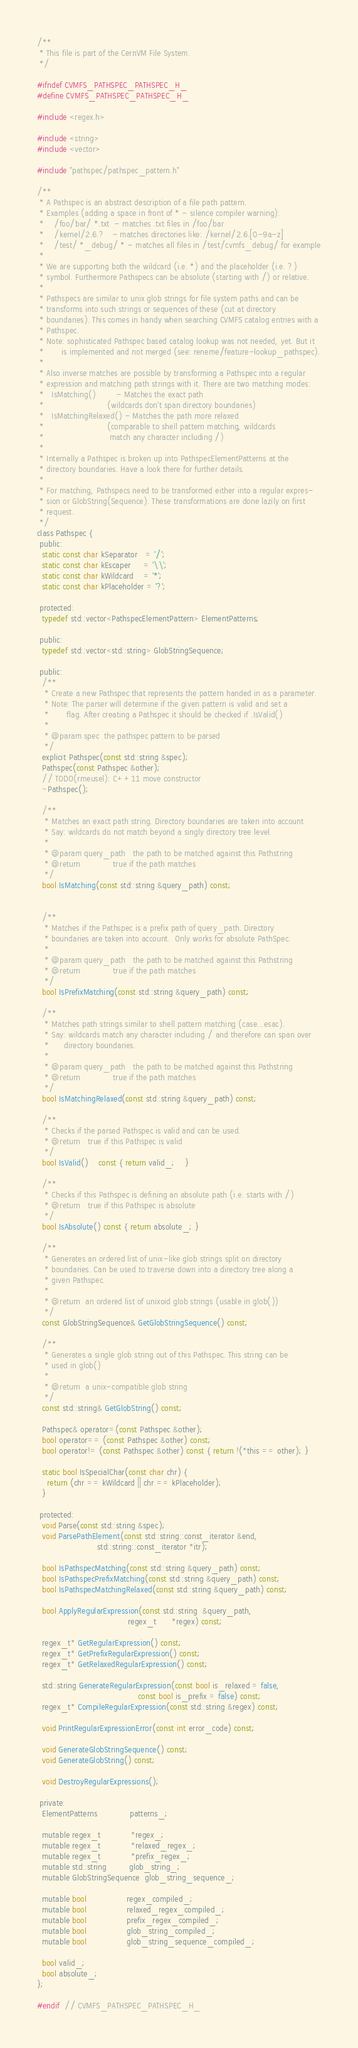Convert code to text. <code><loc_0><loc_0><loc_500><loc_500><_C_>/**
 * This file is part of the CernVM File System.
 */

#ifndef CVMFS_PATHSPEC_PATHSPEC_H_
#define CVMFS_PATHSPEC_PATHSPEC_H_

#include <regex.h>

#include <string>
#include <vector>

#include "pathspec/pathspec_pattern.h"

/**
 * A Pathspec is an abstract description of a file path pattern.
 * Examples (adding a space in front of * - silence compiler warning):
 *    /foo/bar/ *.txt  - matches .txt files in /foo/bar
 *    /kernel/2.6.?   - matches directories like: /kernel/2.6.[0-9a-z]
 *    /test/ *_debug/ * - matches all files in /test/cvmfs_debug/ for example
 *
 * We are supporting both the wildcard (i.e. *) and the placeholder (i.e. ?)
 * symbol. Furthermore Pathspecs can be absolute (starting with /) or relative.
 *
 * Pathspecs are similar to unix glob strings for file system paths and can be
 * transforms into such strings or sequences of these (cut at directory
 * boundaries). This comes in handy when searching CVMFS catalog entries with a
 * Pathspec.
 * Note: sophisticated Pathspec based catalog lookup was not needed, yet. But it
 *       is implemented and not merged (see: reneme/feature-lookup_pathspec).
 *
 * Also inverse matches are possible by transforming a Pathspec into a regular
 * expression and matching path strings with it. There are two matching modes:
 *   IsMatching()        - Matches the exact path
 *                         (wildcards don't span directory boundaries)
 *   IsMatchingRelaxed() - Matches the path more relaxed
 *                         (comparable to shell pattern matching, wildcards
 *                          match any character including /)
 *
 * Internally a Pathspec is broken up into PathspecElementPatterns at the
 * directory boundaries. Have a look there for further details.
 *
 * For matching, Pathspecs need to be transformed either into a regular expres-
 * sion or GlobString(Sequence). These transformations are done lazily on first
 * request.
 */
class Pathspec {
 public:
  static const char kSeparator   = '/';
  static const char kEscaper     = '\\';
  static const char kWildcard    = '*';
  static const char kPlaceholder = '?';

 protected:
  typedef std::vector<PathspecElementPattern> ElementPatterns;

 public:
  typedef std::vector<std::string> GlobStringSequence;

 public:
  /**
   * Create a new Pathspec that represents the pattern handed in as a parameter.
   * Note: The parser will determine if the given pattern is valid and set a
   *       flag. After creating a Pathspec it should be checked if .IsValid()
   *
   * @param spec  the pathspec pattern to be parsed
   */
  explicit Pathspec(const std::string &spec);
  Pathspec(const Pathspec &other);
  // TODO(rmeusel): C++11 move constructor
  ~Pathspec();

  /**
   * Matches an exact path string. Directory boundaries are taken into account
   * Say: wildcards do not match beyond a singly directory tree level.
   *
   * @param query_path   the path to be matched against this Pathstring
   * @return             true if the path matches
   */
  bool IsMatching(const std::string &query_path) const;


  /**
   * Matches if the Pathspec is a prefix path of query_path. Directory
   * boundaries are taken into account.  Only works for absolute PathSpec.
   *
   * @param query_path   the path to be matched against this Pathstring
   * @return             true if the path matches
   */
  bool IsPrefixMatching(const std::string &query_path) const;

  /**
   * Matches path strings similar to shell pattern matching (case...esac).
   * Say: wildcards match any character including / and therefore can span over
   *      directory boundaries.
   *
   * @param query_path   the path to be matched against this Pathstring
   * @return             true if the path matches
   */
  bool IsMatchingRelaxed(const std::string &query_path) const;

  /**
   * Checks if the parsed Pathspec is valid and can be used.
   * @return   true if this Pathspec is valid
   */
  bool IsValid()    const { return valid_;    }

  /**
   * Checks if this Pathspec is defining an absolute path (i.e. starts with /)
   * @return   true if this Pathspec is absolute
   */
  bool IsAbsolute() const { return absolute_; }

  /**
   * Generates an ordered list of unix-like glob strings split on directory
   * boundaries. Can be used to traverse down into a directory tree along a
   * given Pathspec.
   *
   * @return  an ordered list of unixoid glob strings (usable in glob())
   */
  const GlobStringSequence& GetGlobStringSequence() const;

  /**
   * Generates a single glob string out of this Pathspec. This string can be
   * used in glob()
   *
   * @return  a unix-compatible glob string
   */
  const std::string& GetGlobString() const;

  Pathspec& operator=(const Pathspec &other);
  bool operator== (const Pathspec &other) const;
  bool operator!= (const Pathspec &other) const { return !(*this == other); }

  static bool IsSpecialChar(const char chr) {
    return (chr == kWildcard || chr == kPlaceholder);
  }

 protected:
  void Parse(const std::string &spec);
  void ParsePathElement(const std::string::const_iterator &end,
                        std::string::const_iterator *itr);

  bool IsPathspecMatching(const std::string &query_path) const;
  bool IsPathspecPrefixMatching(const std::string &query_path) const;
  bool IsPathspecMatchingRelaxed(const std::string &query_path) const;

  bool ApplyRegularExpression(const std::string  &query_path,
                                    regex_t      *regex) const;

  regex_t* GetRegularExpression() const;
  regex_t* GetPrefixRegularExpression() const;
  regex_t* GetRelaxedRegularExpression() const;

  std::string GenerateRegularExpression(const bool is_relaxed = false,
                                        const bool is_prefix = false) const;
  regex_t* CompileRegularExpression(const std::string &regex) const;

  void PrintRegularExpressionError(const int error_code) const;

  void GenerateGlobStringSequence() const;
  void GenerateGlobString() const;

  void DestroyRegularExpressions();

 private:
  ElementPatterns             patterns_;

  mutable regex_t            *regex_;
  mutable regex_t            *relaxed_regex_;
  mutable regex_t            *prefix_regex_;
  mutable std::string         glob_string_;
  mutable GlobStringSequence  glob_string_sequence_;

  mutable bool                regex_compiled_;
  mutable bool                relaxed_regex_compiled_;
  mutable bool                prefix_regex_compiled_;
  mutable bool                glob_string_compiled_;
  mutable bool                glob_string_sequence_compiled_;

  bool valid_;
  bool absolute_;
};

#endif  // CVMFS_PATHSPEC_PATHSPEC_H_
</code> 